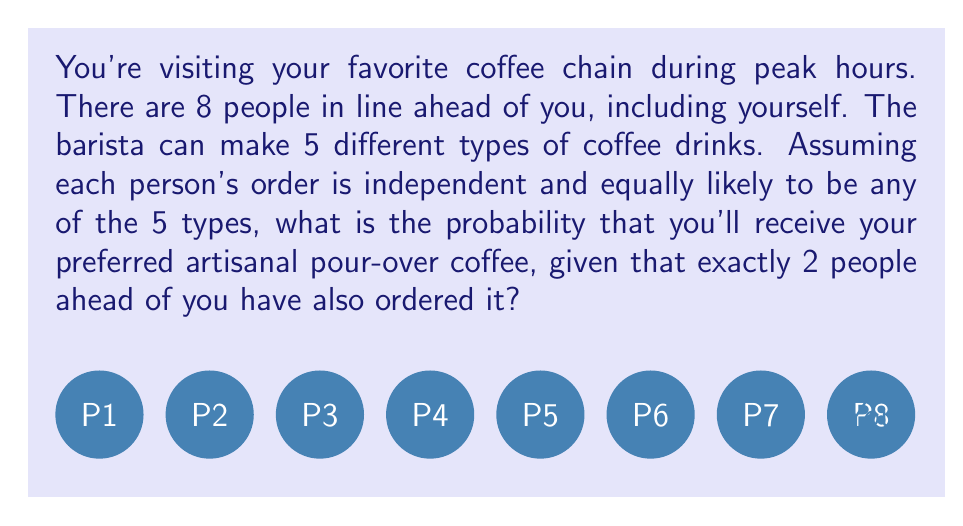Could you help me with this problem? Let's approach this step-by-step:

1) First, we need to calculate the probability of exactly 2 people out of the 7 ahead of you ordering the pour-over coffee.

2) This follows a binomial distribution with parameters:
   $n = 7$ (number of people ahead of you)
   $p = \frac{1}{5}$ (probability of each person ordering pour-over)
   $k = 2$ (number of successes we want)

3) The probability is given by the binomial probability formula:

   $$P(X=k) = \binom{n}{k} p^k (1-p)^{n-k}$$

4) Substituting our values:

   $$P(X=2) = \binom{7}{2} (\frac{1}{5})^2 (\frac{4}{5})^5$$

5) Calculate:
   $$\binom{7}{2} = \frac{7!}{2!(7-2)!} = 21$$

6) Now our equation is:

   $$P(X=2) = 21 \cdot (\frac{1}{25}) \cdot (\frac{1024}{3125}) \approx 0.2362$$

7) Given that exactly 2 people ahead ordered pour-over, the probability that you also order it is simply $\frac{1}{5}$, as your order is independent.

8) Therefore, the final probability is the product of these two probabilities:

   $$0.2362 \cdot \frac{1}{5} \approx 0.04724$$
Answer: $\approx 0.04724$ or $4.724\%$ 